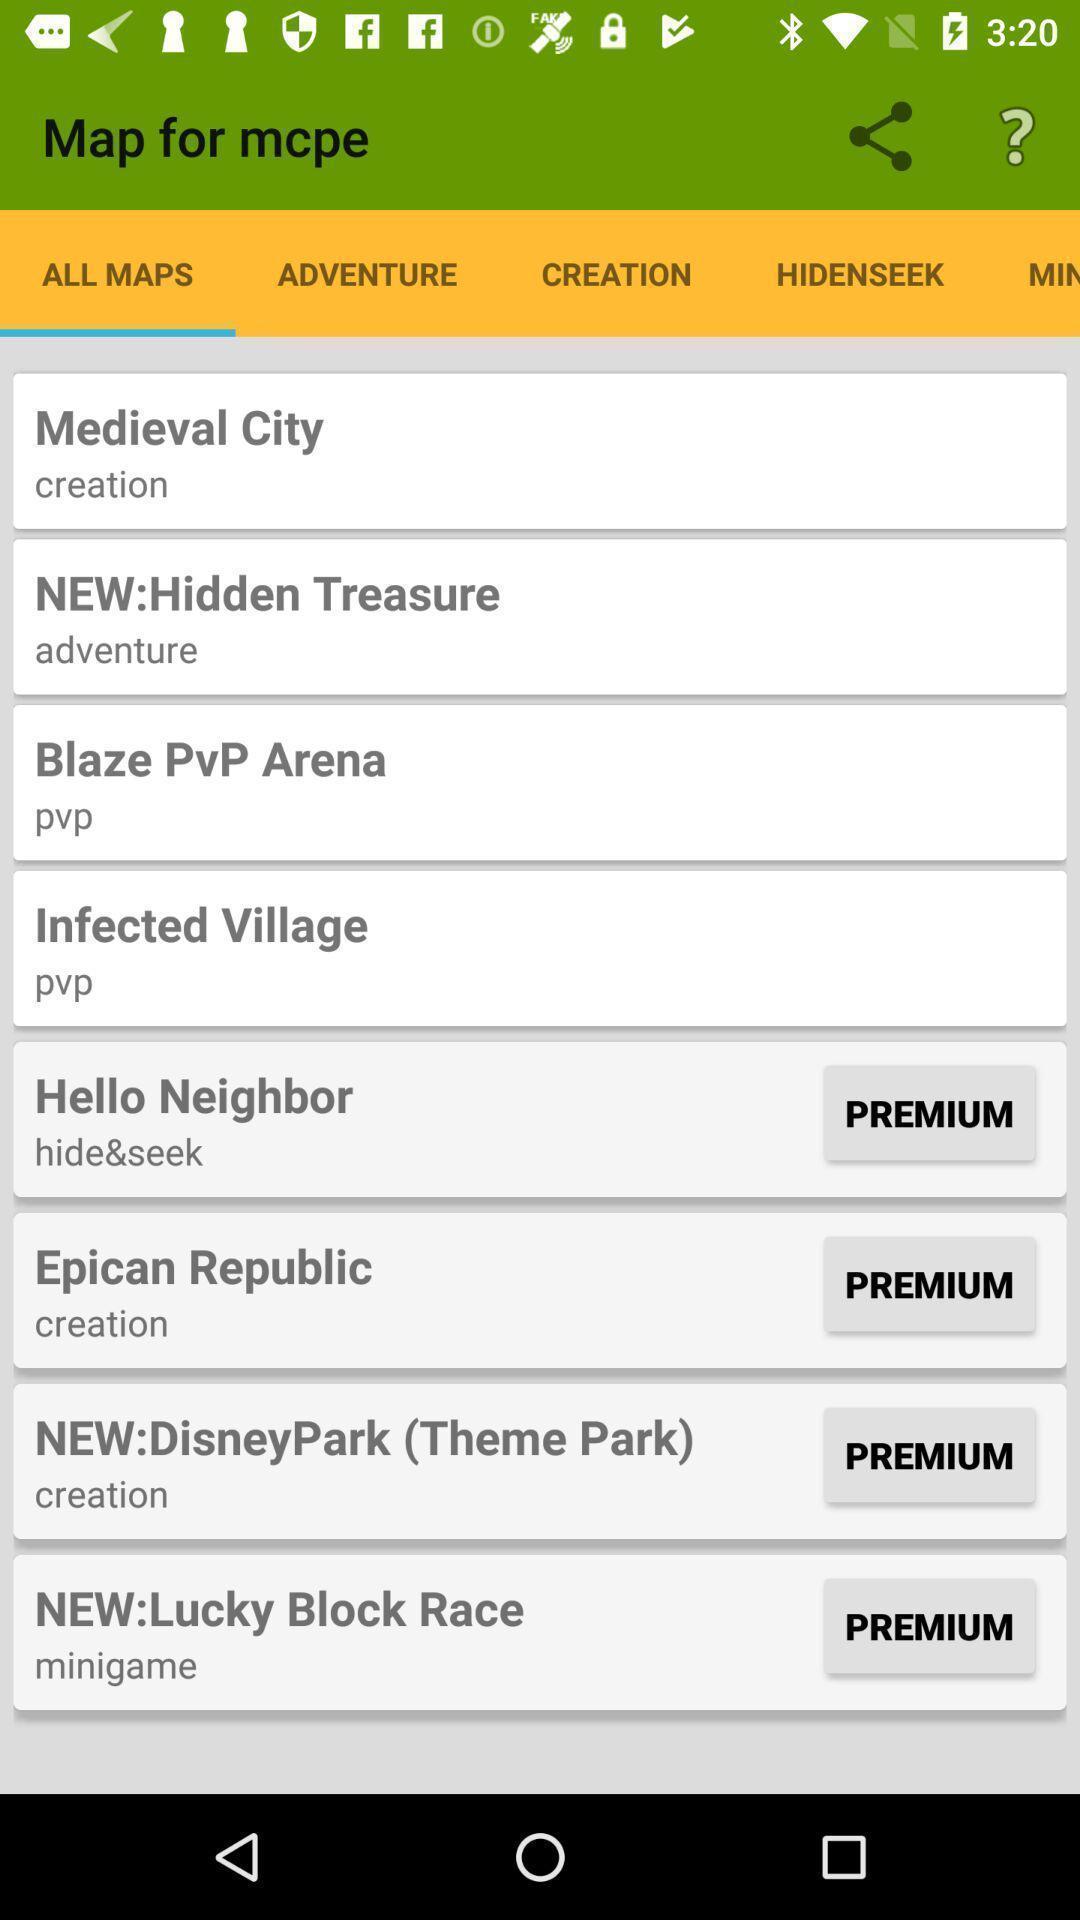Describe the visual elements of this screenshot. Window displaying list of all maps. 